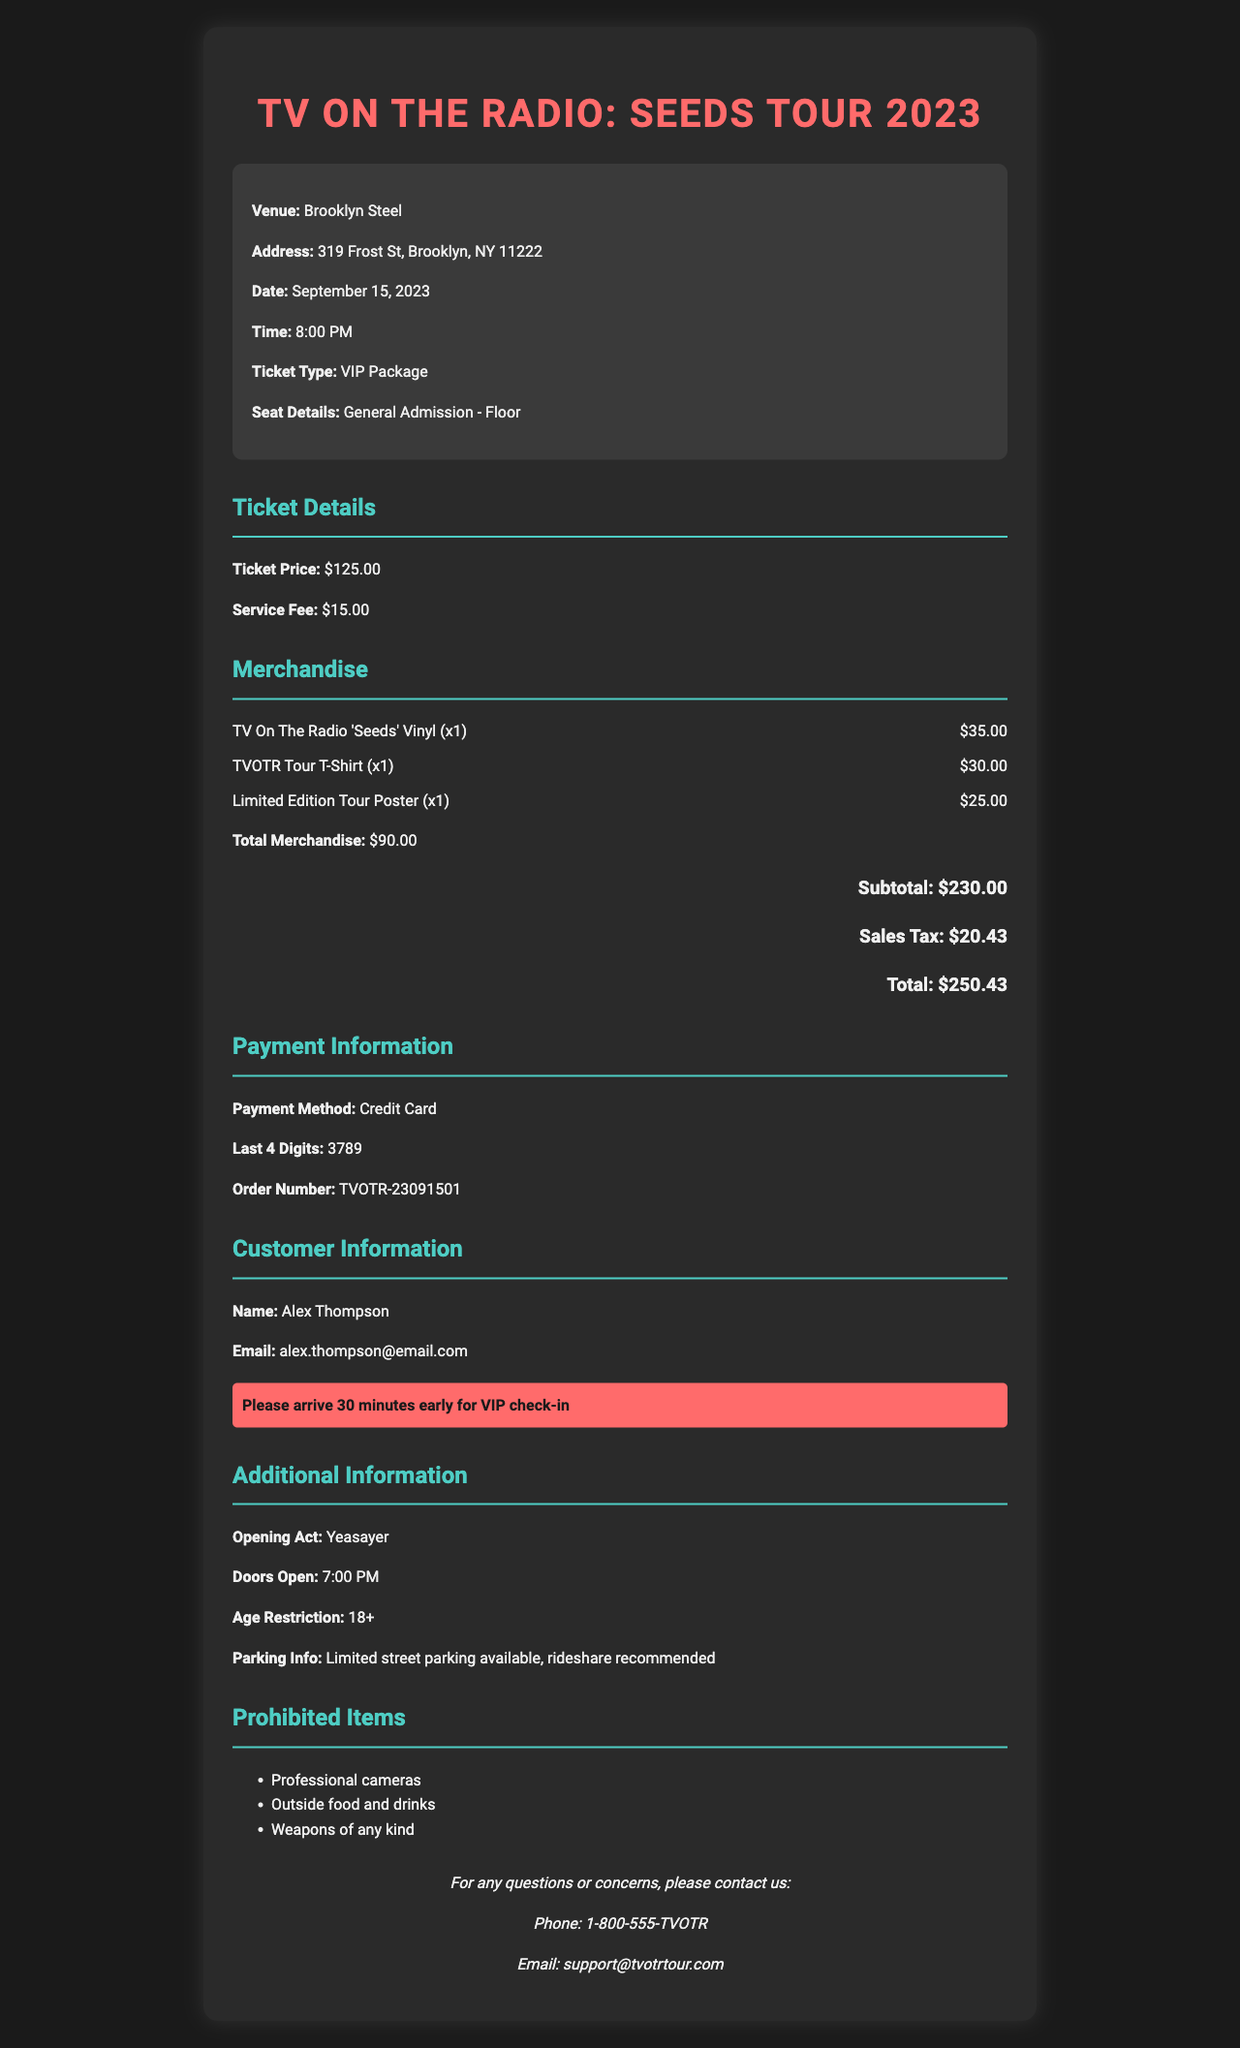what is the event name? The event name is listed prominently at the top of the document.
Answer: TV On The Radio: Seeds Tour 2023 what is the date of the concert? The date of the concert is specified in the event details section.
Answer: September 15, 2023 what seat details are provided? The seat details describe the seating arrangement for the ticket purchased.
Answer: General Admission - Floor what is the total cost of the ticket? The total cost of the ticket is calculated by adding the ticket price and the service fee.
Answer: $140.00 how many merchandise items were purchased? The number of merchandise items can be found by counting the merchandise entries.
Answer: 3 what is the total merchandise cost? The total merchandise cost is listed under the merchandise section of the document.
Answer: $90.00 what is the order number? The order number is a unique identifier for the transaction, found in the payment information section.
Answer: TVOTR-23091501 who is the opening act for the concert? The opening act is mentioned in the additional information section of the document.
Answer: Yeasayer what special instructions are provided? The special instructions give details on arrival for VIP check-in.
Answer: Please arrive 30 minutes early for VIP check-in what is the minimum age requirement for attendees? The age restriction is explicitly stated in the additional information section.
Answer: 18+ 